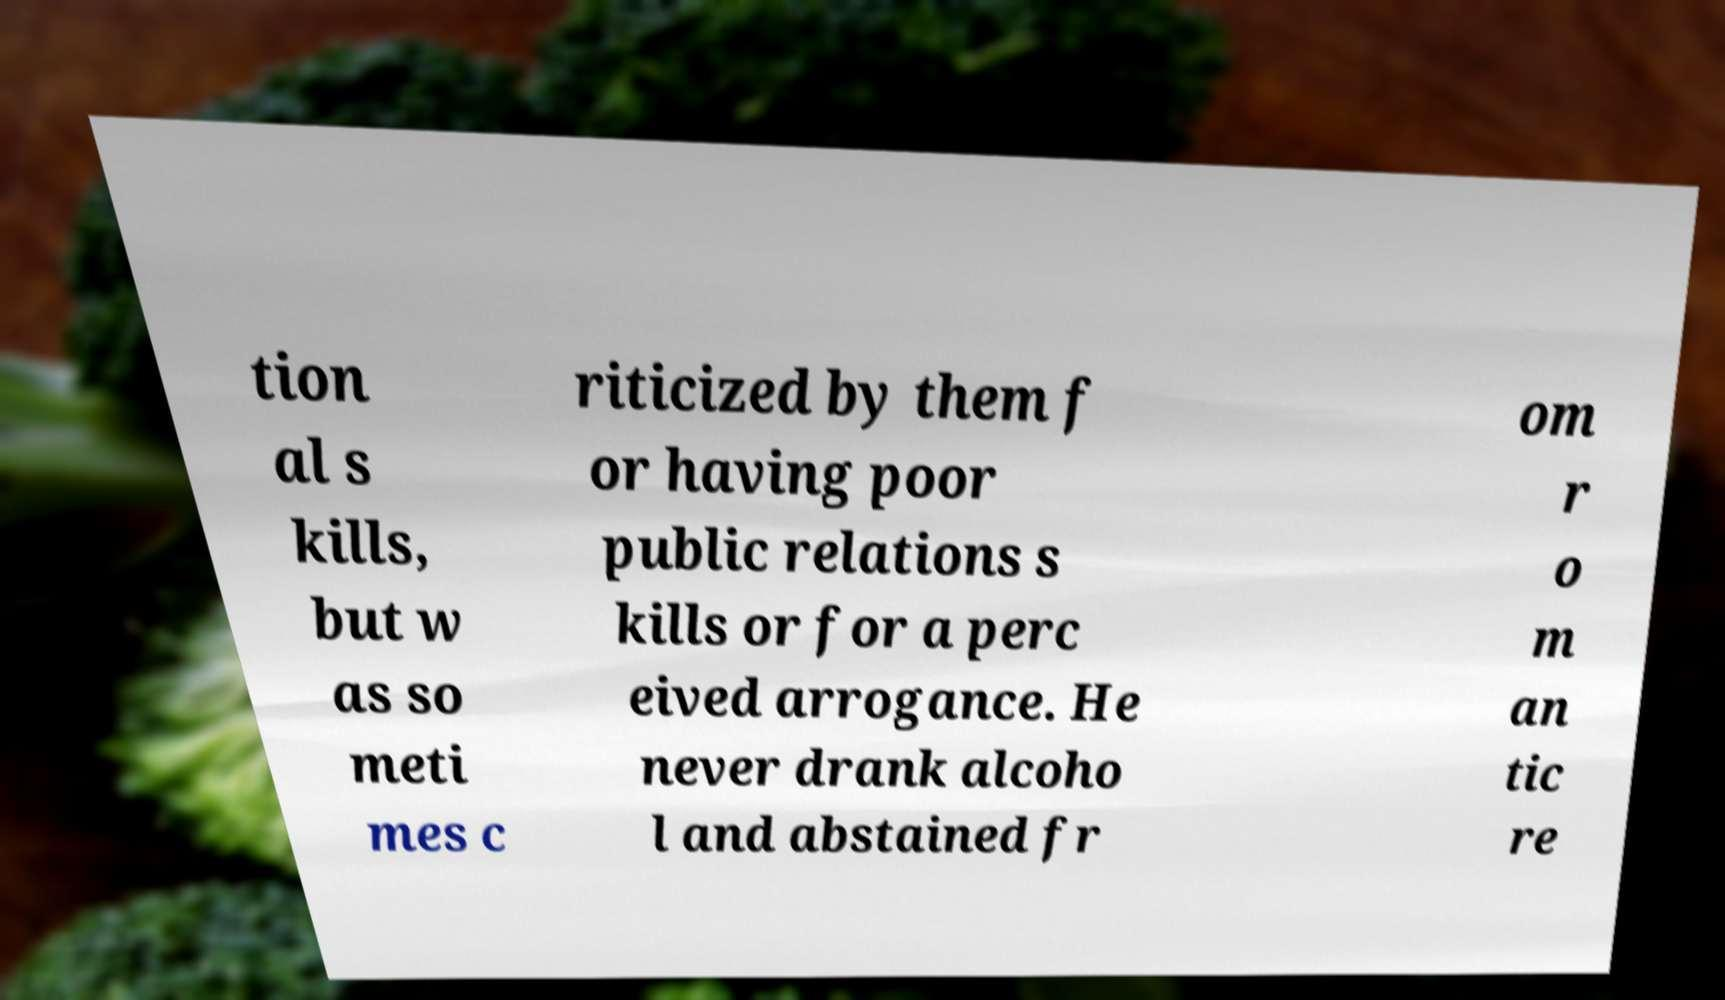Can you read and provide the text displayed in the image?This photo seems to have some interesting text. Can you extract and type it out for me? tion al s kills, but w as so meti mes c riticized by them f or having poor public relations s kills or for a perc eived arrogance. He never drank alcoho l and abstained fr om r o m an tic re 